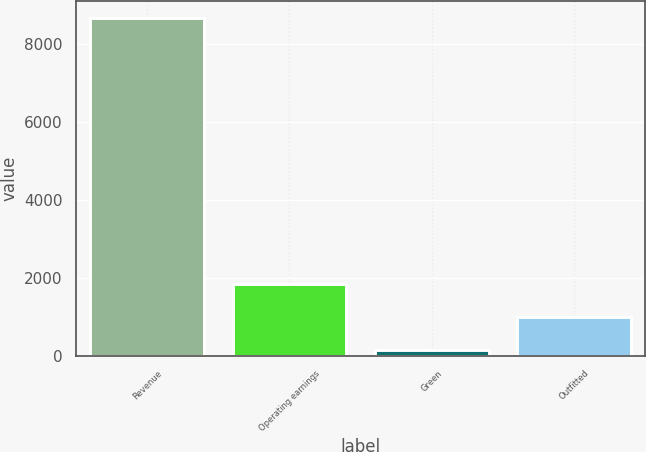Convert chart to OTSL. <chart><loc_0><loc_0><loc_500><loc_500><bar_chart><fcel>Revenue<fcel>Operating earnings<fcel>Green<fcel>Outfitted<nl><fcel>8649<fcel>1845<fcel>144<fcel>994.5<nl></chart> 